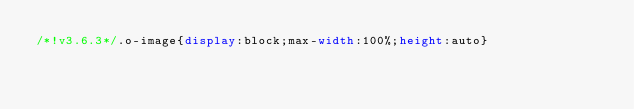<code> <loc_0><loc_0><loc_500><loc_500><_CSS_>/*!v3.6.3*/.o-image{display:block;max-width:100%;height:auto}</code> 